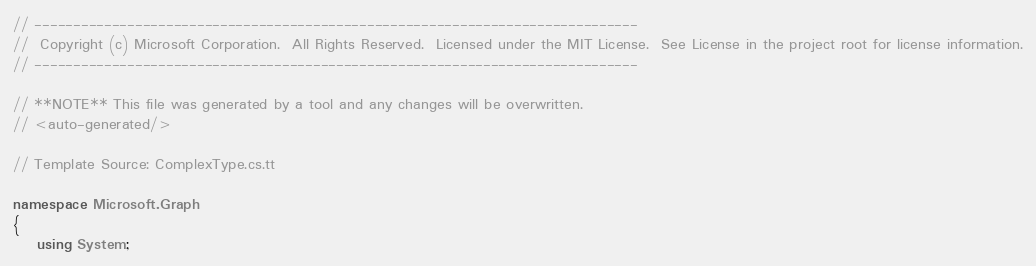<code> <loc_0><loc_0><loc_500><loc_500><_C#_>// ------------------------------------------------------------------------------
//  Copyright (c) Microsoft Corporation.  All Rights Reserved.  Licensed under the MIT License.  See License in the project root for license information.
// ------------------------------------------------------------------------------

// **NOTE** This file was generated by a tool and any changes will be overwritten.
// <auto-generated/>

// Template Source: ComplexType.cs.tt

namespace Microsoft.Graph
{
    using System;</code> 